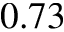<formula> <loc_0><loc_0><loc_500><loc_500>0 . 7 3</formula> 